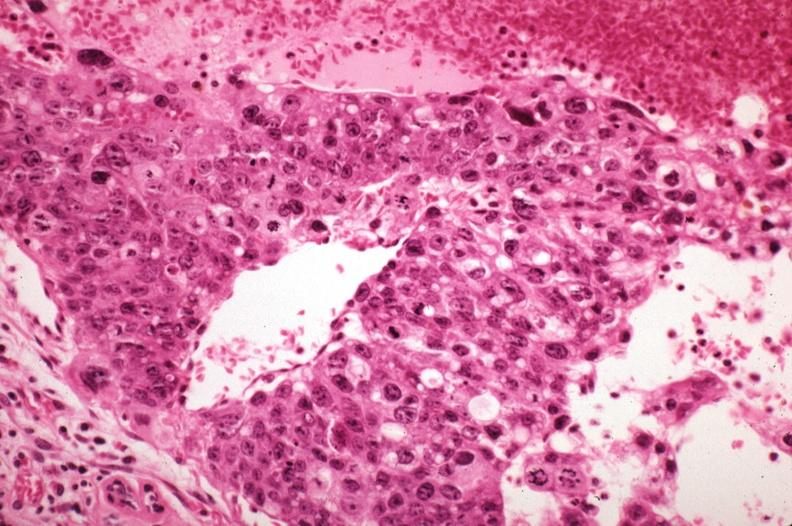what is metastatic choriocarcinoma with pleomorphism and mitotic figures sickled?
Answer the question using a single word or phrase. Red cells in vessels well shown 